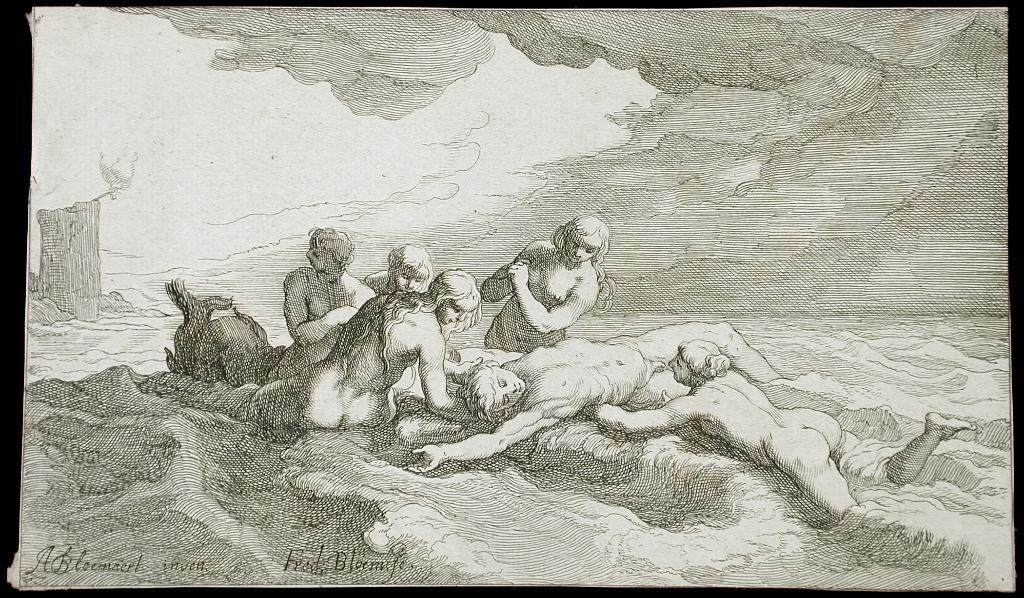What type of medium is the image created on? The image is a canvas. What is the main subject of the image? There is a person lying down in the image. Are there any other people present in the image? Yes, there are people surrounding the lying person in the image. What type of yard is visible in the image? There is no yard present in the image; it is a canvas painting. 